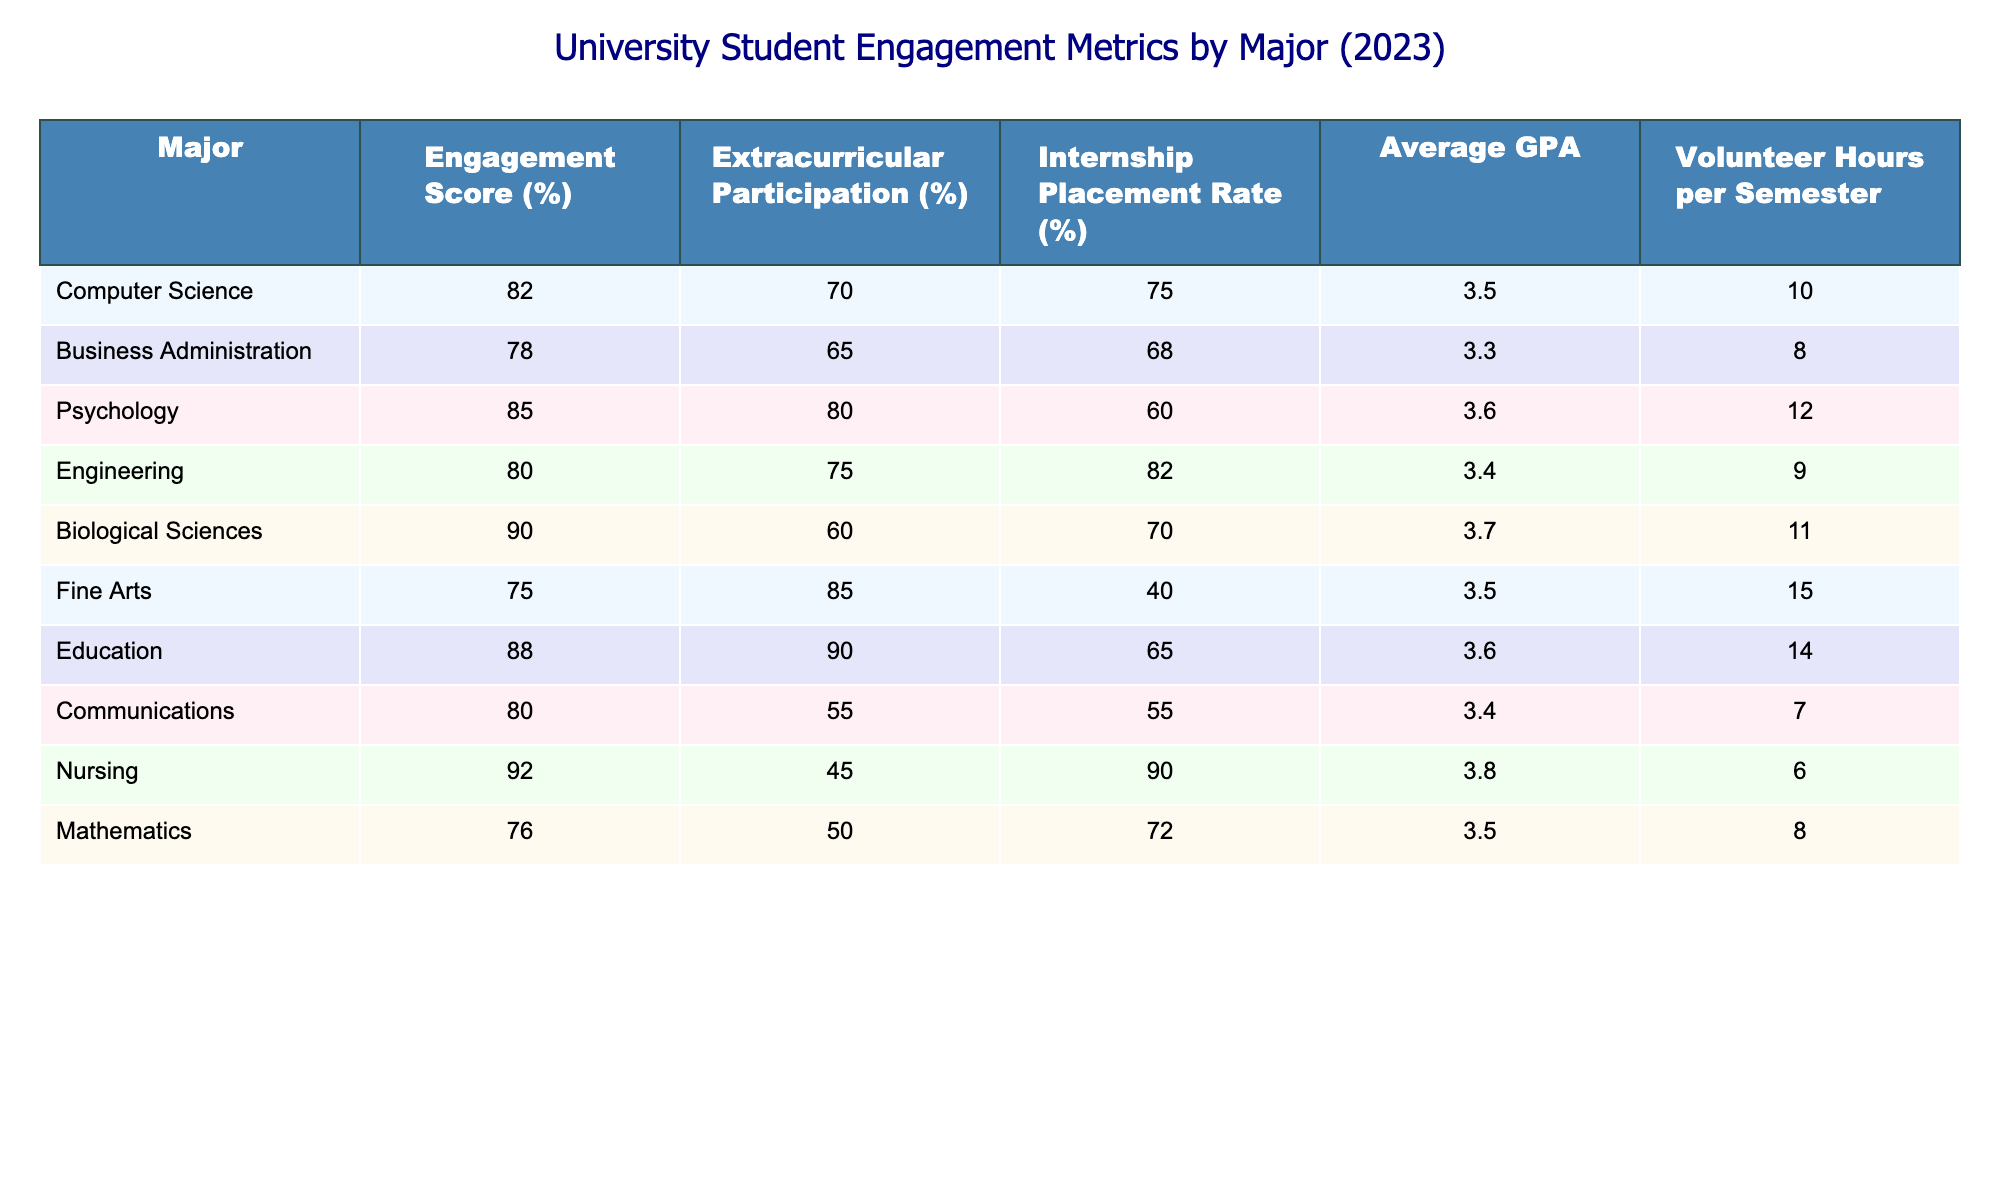What is the engagement score for Psychology majors? The table lists the engagement scores by major. For Psychology, it is given as 85%.
Answer: 85% Which major has the highest average GPA? By looking at the average GPA column, the major with the highest average is Nursing with an average GPA of 3.8.
Answer: Nursing What is the difference between the extracurricular participation rates of Fine Arts and Engineering majors? Fine Arts has an extracurricular participation rate of 85%, while Engineering has a rate of 75%. The difference is 85% - 75% = 10%.
Answer: 10% Are students in Biological Sciences more likely to participate in internships compared to those in Business Administration? Looking at the internship placement rates, Biological Sciences has a rate of 70%, while Business Administration has a rate of 68%. Since 70% is greater than 68%, the statement is true.
Answer: Yes What is the average volunteer hours per semester for students majoring in Education and Psychology? The table indicates that Education students have 14 volunteer hours and Psychology students have 12 volunteer hours. To find the average, add these two values (14 + 12) = 26 and divide by 2, giving an average of 13 hours.
Answer: 13 How many majors have an engagement score below 80%? By examining the engagement scores, we find that Business Administration (78%), Fine Arts (75%), and Mathematics (76%) have scores below 80%. This totals to 3 majors.
Answer: 3 What is the total internship placement rate for Engineering and Computer Science combined? The internship placement rate for Engineering is 82% and Computer Science is 75%. Adding these two rates together: 82% + 75% = 157%.
Answer: 157% Which major has the lowest volunteer hours per semester? Looking at the volunteer hours column, Nursing has 6 hours per semester, which is the lowest compared to other majors.
Answer: Nursing What is the engagement score for the major with the highest internship placement rate? The major with the highest internship placement rate is Nursing at 90%. Therefore, the engagement score for Nursing is also 92%.
Answer: 92% 